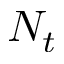Convert formula to latex. <formula><loc_0><loc_0><loc_500><loc_500>N _ { t }</formula> 